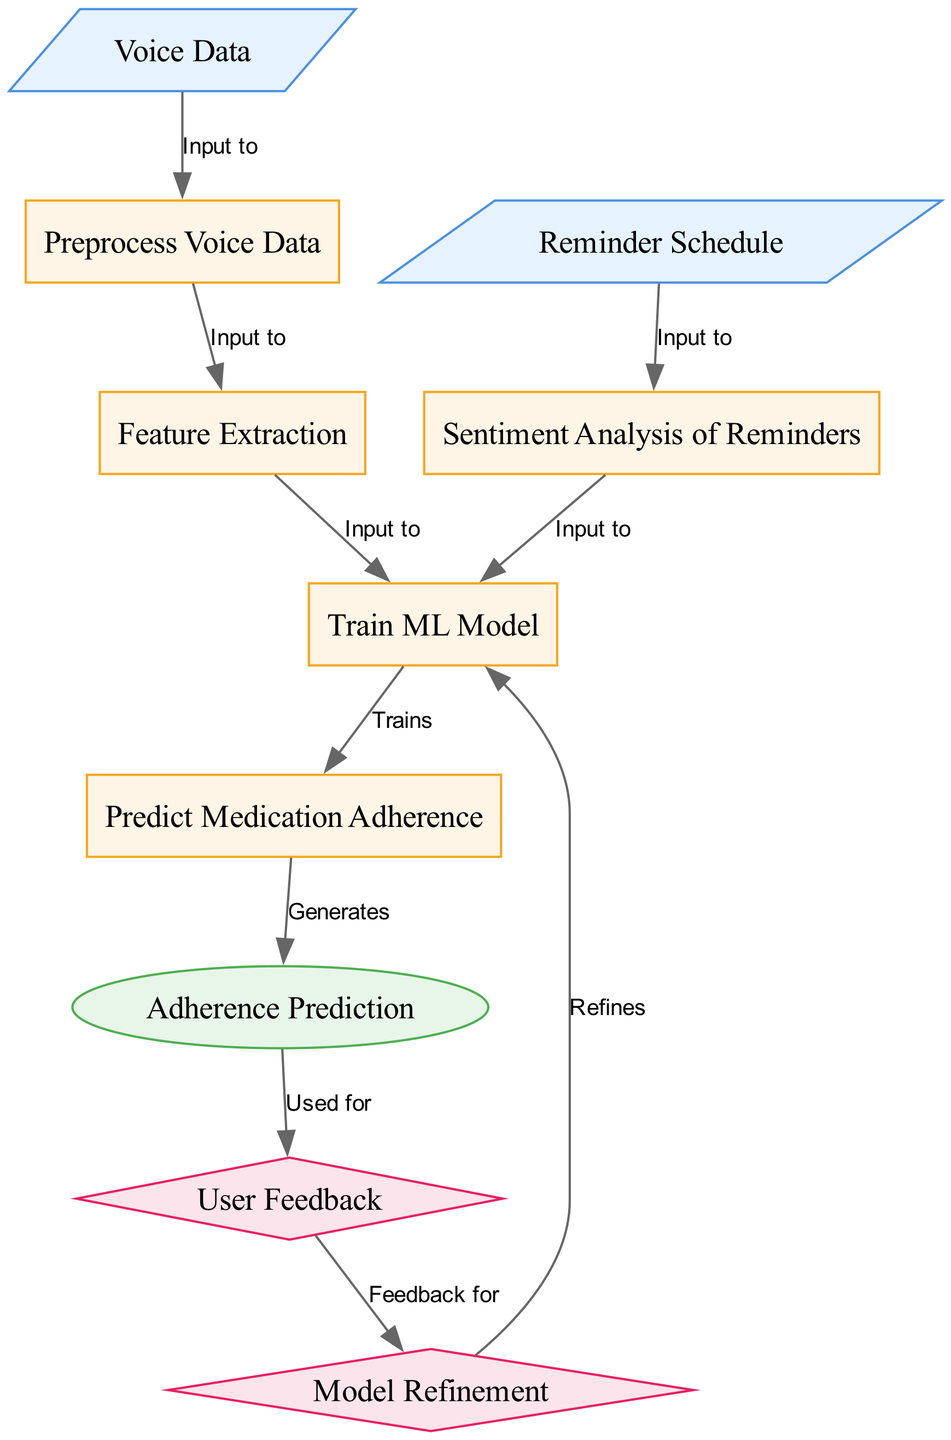What are the input data types in this diagram? The diagram contains two input data types: "Voice Data" and "Reminder Schedule". These are the nodes labeled "Voice Data" and "Reminder Schedule", which feed into processing steps in the system.
Answer: Voice Data, Reminder Schedule How many nodes are present in this diagram? The diagram features a total of ten nodes, each representing a different part of the medication adherence prediction process.
Answer: 10 What is the function of the "Train ML Model" node? The "Train ML Model" node receives processed inputs from both voice data and sentiment analysis of reminders to develop a machine learning model for predicting medication adherence.
Answer: Trains ML Model Which node receives input from the "output_adherence_prediction" node? The "output_adherence_prediction" node directly sends its information to the "user_feedback" node, which collects feedback based on the predictions made by the model.
Answer: User Feedback What does the "User Feedback" node provide to the "Model Refinement" node? The "User Feedback" node generates feedback that is utilized by the "Model Refinement" node to improve the training process and adjust the machine learning model accordingly.
Answer: Feedback for Model Refinement Which step comes before the "Predict Medication Adherence" node? The "Predict Medication Adherence" node follows after the "Train ML Model" node, meaning the training must be completed before making predictions about medication adherence.
Answer: Train ML Model In which type of analysis does the "Reminder Schedule" input participate? The "Reminder Schedule" input is involved in "Sentiment Analysis of Reminders", where the feelings or tones of the reminders are analyzed to assist in predicting adherence.
Answer: Sentiment Analysis of Reminders What does the output of the "Predict Medication Adherence" node generate? The output generated from the "Predict Medication Adherence" node is labeled as "Adherence Prediction", indicating the result of the compliance assessment.
Answer: Adherence Prediction Which kinds of nodes are the feedback-related components in the diagram? The feedback-related components are the "User Feedback" and "Model Refinement" nodes, which together facilitate a loop for improving the model based on user experiences.
Answer: User Feedback, Model Refinement 